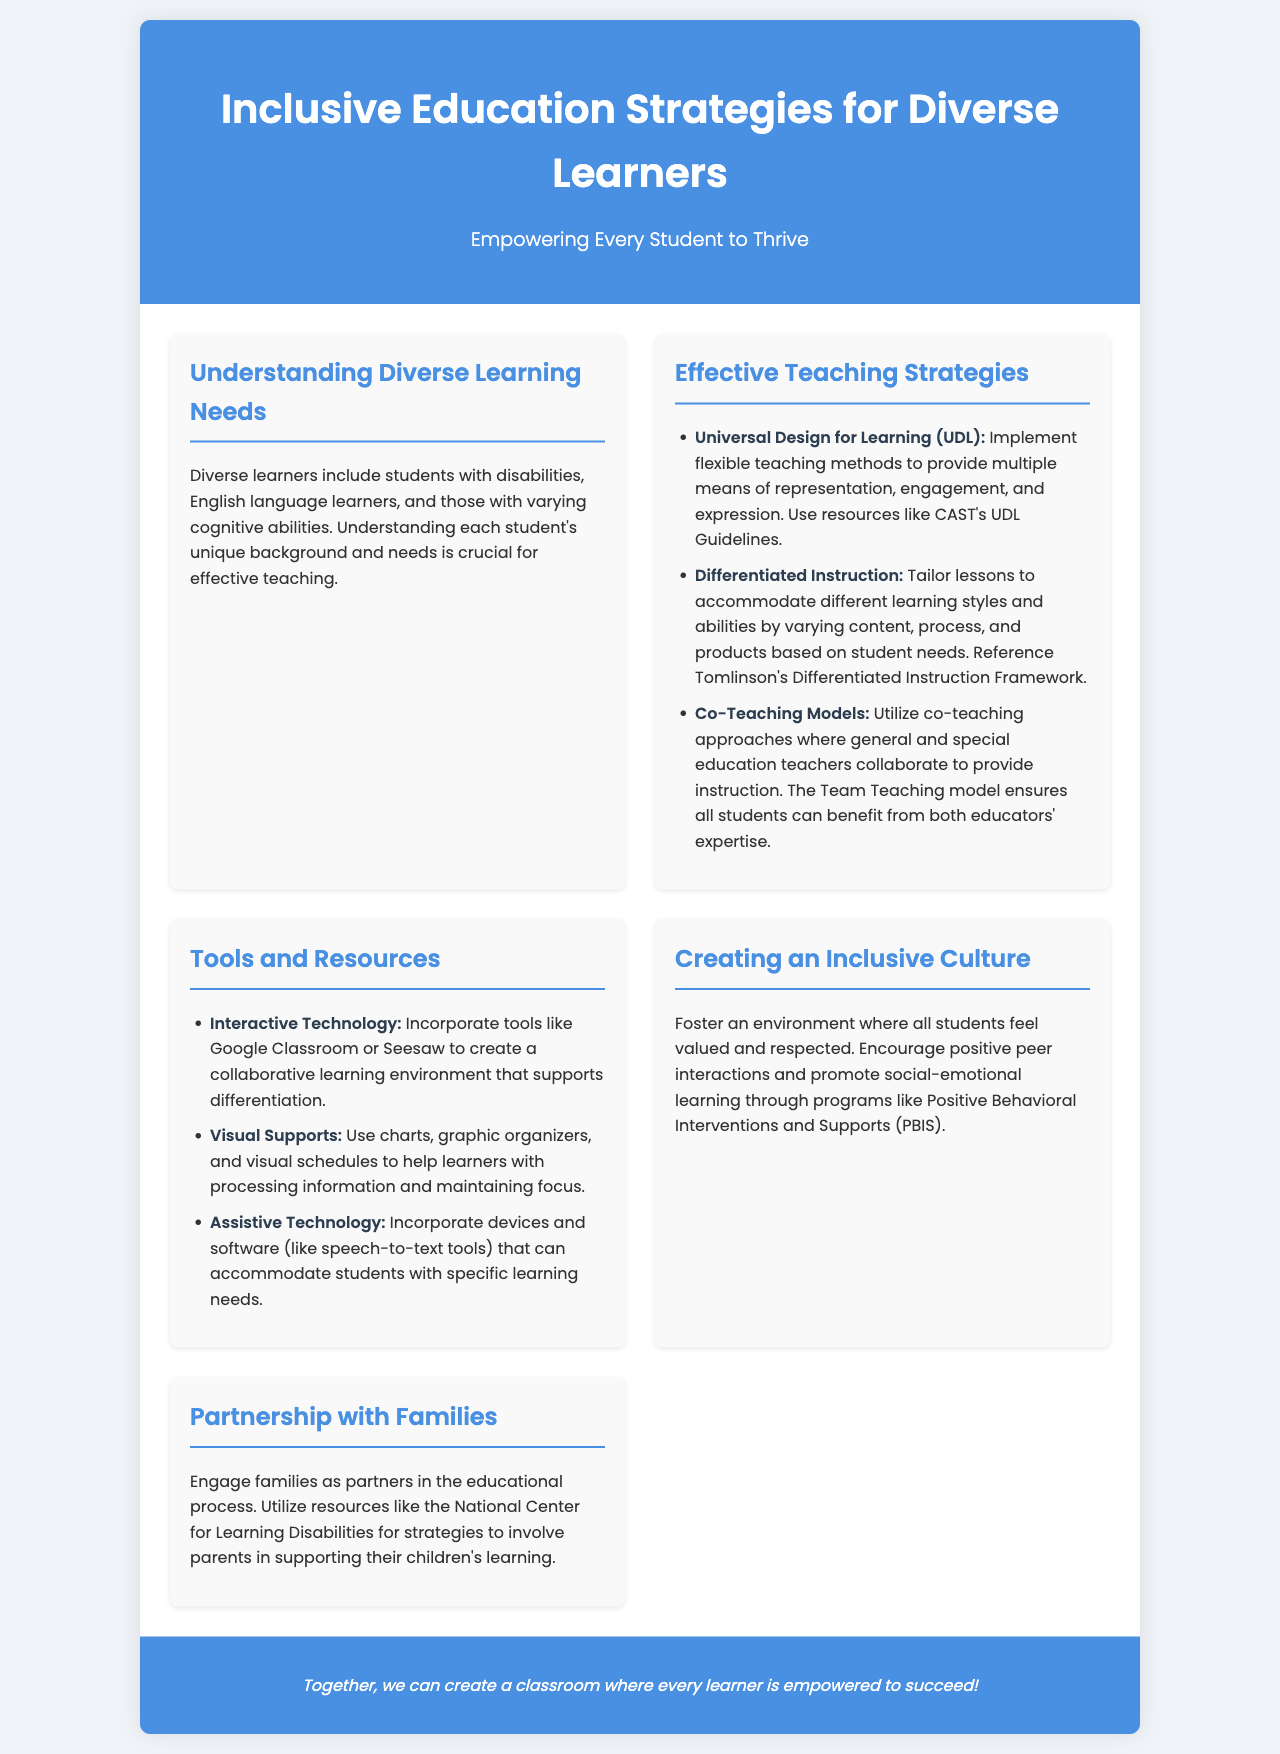What is the title of the brochure? The title can be found in the header section of the document.
Answer: Inclusive Education Strategies for Diverse Learners What is the subtitle of the brochure? The subtitle is a brief phrase under the title in the header section.
Answer: Empowering Every Student to Thrive What are the three effective teaching strategies mentioned? These strategies are listed in the Effective Teaching Strategies section of the document.
Answer: Universal Design for Learning, Differentiated Instruction, Co-Teaching Models What is one tool suggested for creating a collaborative learning environment? The tool is mentioned in the Tools and Resources section of the document.
Answer: Google Classroom Which model is mentioned for fostering positive peer interactions? The program is referenced in the Creating an Inclusive Culture section.
Answer: Positive Behavioral Interventions and Supports (PBIS) What is a key focus for engaging families in education? This focus can be found in the Partnership with Families section.
Answer: Strategies to involve parents in supporting their children's learning How many sections are there in the main content of the brochure? The total number of sections is counted in the main content area of the document.
Answer: Five What is the background color of the footer? The background color is described as part of the footer styling in the document.
Answer: #4a90e2 